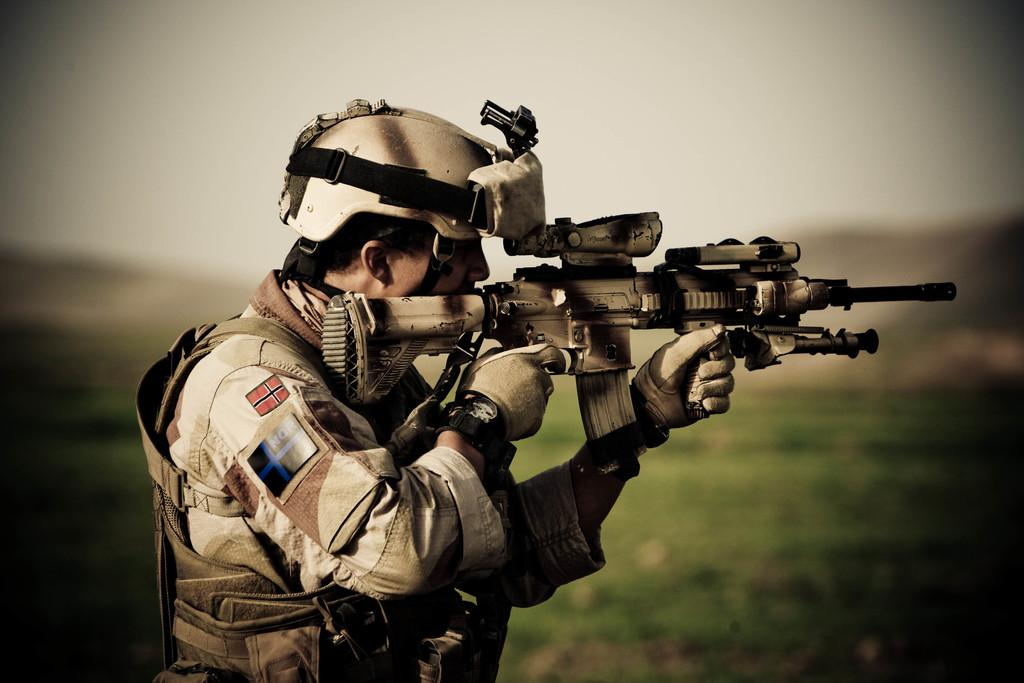What is the main subject of the image? There is a person in the image. What type of clothing is the person wearing? The person is wearing a uniform and a helmet. What other protective gear is the person wearing? The person is also wearing gloves. What object is the person holding? The person is holding a gun. What type of surface can be seen in the image? There is ground visible in the image. What type of vessel is the actor using to paint the picture in the image? There is no vessel, actor, or painting activity present in the image. 